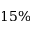<formula> <loc_0><loc_0><loc_500><loc_500>1 5 \%</formula> 